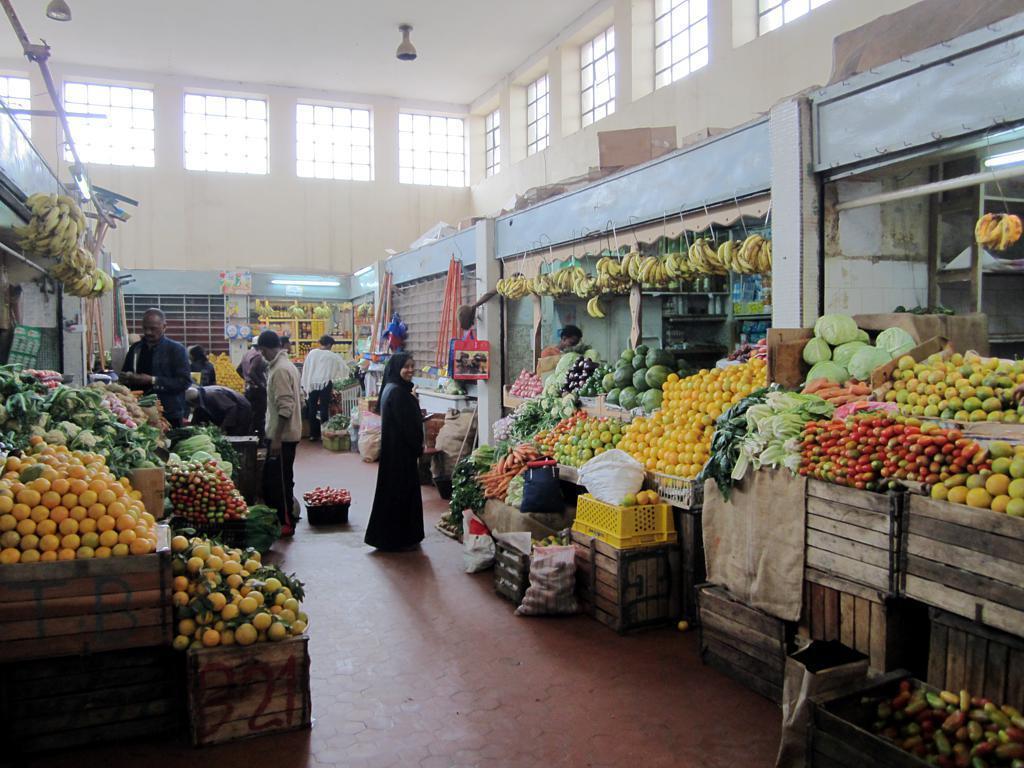Please provide a concise description of this image. I think this picture was taken in the market. There are few people standing. These are the lights attached to the roof. I can see the windows. Here is the fruits and vegetable shops with a bunch of oranges, bananas, cabbage, cauliflower and few other fruits or vegetables. 